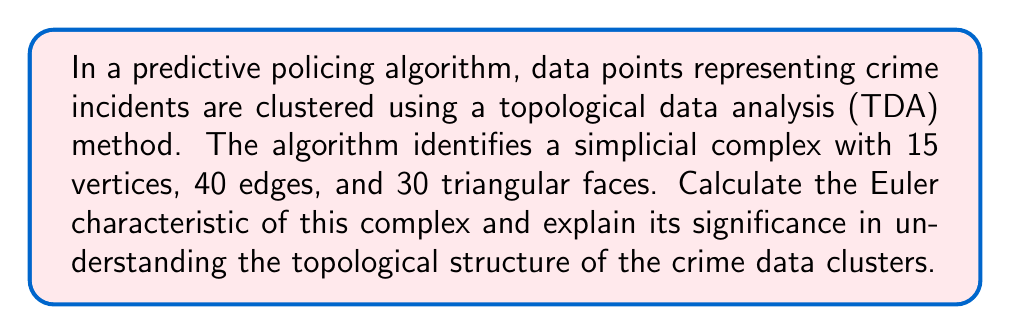Provide a solution to this math problem. To solve this problem, we need to follow these steps:

1. Understand the Euler characteristic:
   The Euler characteristic ($\chi$) is a topological invariant that describes the shape or structure of a topological space. For a simplicial complex, it is calculated using the formula:

   $$\chi = V - E + F$$

   Where:
   $V$ = number of vertices
   $E$ = number of edges
   $F$ = number of faces

2. Apply the given values to the formula:
   $V = 15$ (vertices)
   $E = 40$ (edges)
   $F = 30$ (triangular faces)

   $$\chi = 15 - 40 + 30$$

3. Calculate the result:
   $$\chi = 5$$

4. Interpret the result:
   The Euler characteristic of 5 provides insights into the topological structure of the crime data clusters:

   a) It indicates that the simplicial complex is not a simple sphere (which would have $\chi = 2$) or a torus (which would have $\chi = 0$).
   
   b) A positive Euler characteristic suggests that the complex has more "hole-filling" components (vertices and faces) than "hole-creating" components (edges).
   
   c) This could imply that the crime data clusters have a relatively complex structure with multiple connected components or cavities.

5. Legal and ethical implications:
   As a legal scholar, it's important to consider that:

   a) The topological structure of the data clusters may influence the predictions made by the algorithm, potentially affecting law enforcement decisions.
   
   b) A complex topological structure might make the algorithm's decision-making process less transparent, raising concerns about fairness and accountability in predictive policing.
   
   c) The Euler characteristic alone doesn't provide a complete picture of the data's structure, and additional topological analyses may be necessary to fully understand the ethical implications of using such algorithms in law enforcement.
Answer: The Euler characteristic of the simplicial complex is 5. This indicates a non-trivial topological structure in the crime data clusters, which may have implications for the transparency and fairness of the predictive policing algorithm. 